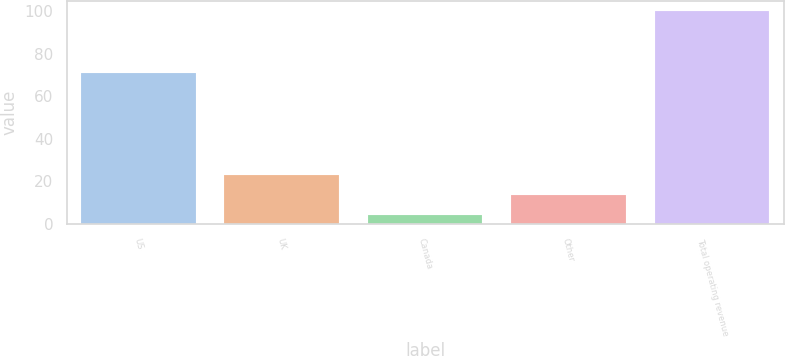<chart> <loc_0><loc_0><loc_500><loc_500><bar_chart><fcel>US<fcel>UK<fcel>Canada<fcel>Other<fcel>Total operating revenue<nl><fcel>71<fcel>23.2<fcel>4<fcel>13.6<fcel>100<nl></chart> 